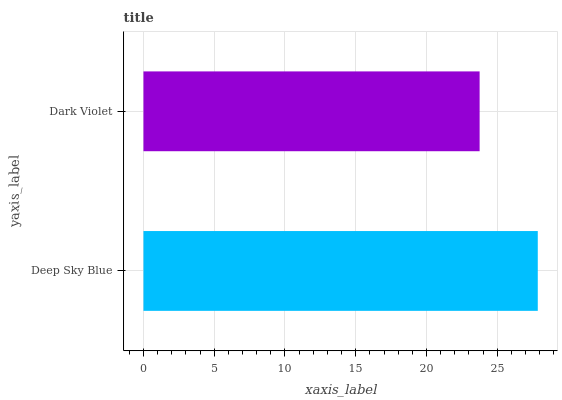Is Dark Violet the minimum?
Answer yes or no. Yes. Is Deep Sky Blue the maximum?
Answer yes or no. Yes. Is Dark Violet the maximum?
Answer yes or no. No. Is Deep Sky Blue greater than Dark Violet?
Answer yes or no. Yes. Is Dark Violet less than Deep Sky Blue?
Answer yes or no. Yes. Is Dark Violet greater than Deep Sky Blue?
Answer yes or no. No. Is Deep Sky Blue less than Dark Violet?
Answer yes or no. No. Is Deep Sky Blue the high median?
Answer yes or no. Yes. Is Dark Violet the low median?
Answer yes or no. Yes. Is Dark Violet the high median?
Answer yes or no. No. Is Deep Sky Blue the low median?
Answer yes or no. No. 